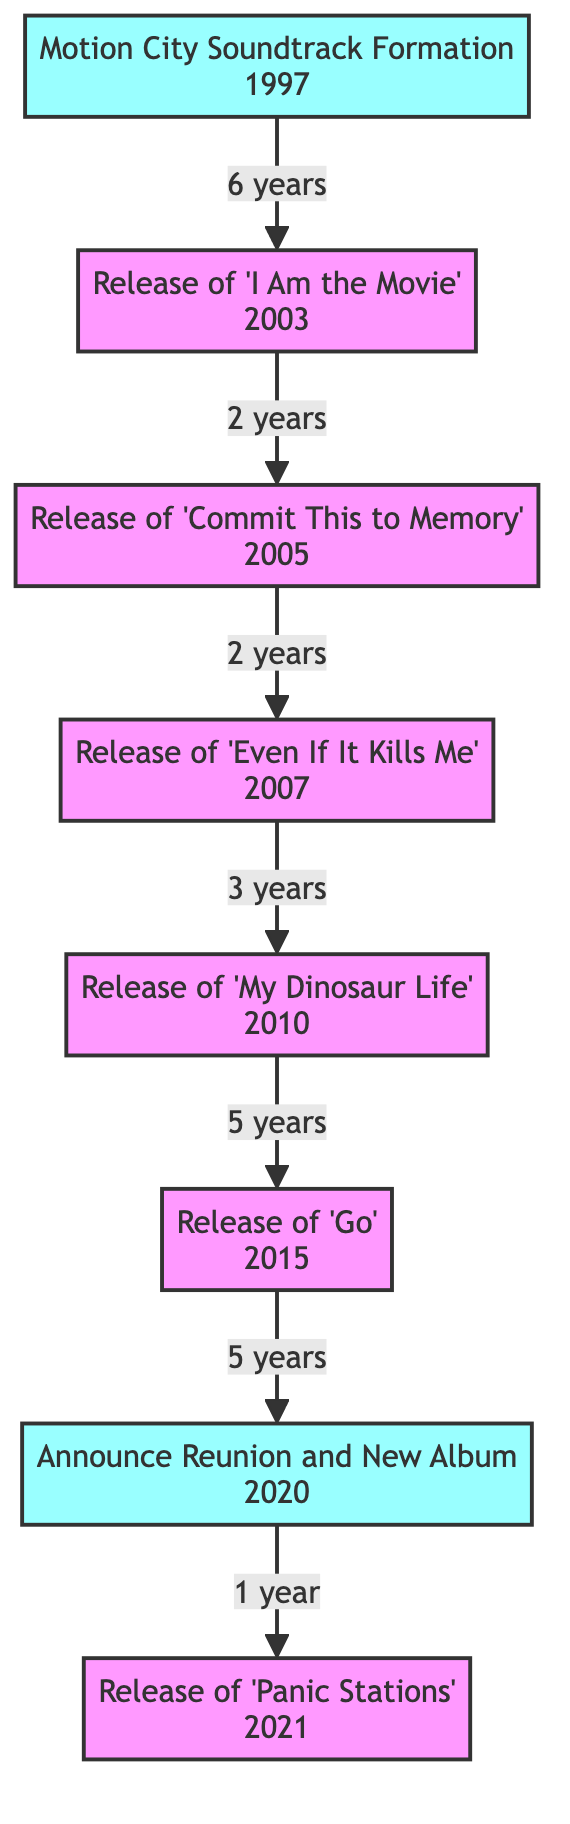What year was Motion City Soundtrack formed? According to the diagram, the formation of Motion City Soundtrack is represented in the first node, which indicates the year 1997.
Answer: 1997 How many albums were released after 'Even If It Kills Me'? Counting the connections from the 'Even If It Kills Me' node, there are two subsequent releases shown: 'My Dinosaur Life' and 'Go'.
Answer: 2 What is the label for node 6? Node 6 is labeled "Release of 'Go'", as indicated in the description next to the corresponding node.
Answer: Release of 'Go' What event took place in 2021? The diagram details the events chronologically, showing that 'Panic Stations' was released in 2021, which can be seen clearly in node 8.
Answer: Release of 'Panic Stations' What is the time span between the formation of the band and the release of their first album? The edge from node 1 (Formation) to node 2 (First Album) states a span of 6 years, clearly indicated by the label on the connecting line in the diagram.
Answer: 6 years What are the milestones highlighted in this diagram? The diagram indicates two milestones: the formation of the band (1997) and the announcement of their reunion (2020), both of which are marked differently in the diagram.
Answer: Motion City Soundtrack Formation, Announce Reunion and New Album How many total nodes are present in the diagram? By counting the individual labeled events and milestones, we can see there are 8 nodes represented in the diagram.
Answer: 8 Which album came out immediately after 'My Dinosaur Life'? The diagram shows that 'Go' is the release that follows 'My Dinosaur Life', connected directly from node 5 to node 6.
Answer: Go When did Motion City Soundtrack announce their reunion? Referring to the diagram, the reunion was announced in 2020, which is clearly stated in node 7 of the diagram.
Answer: 2020 